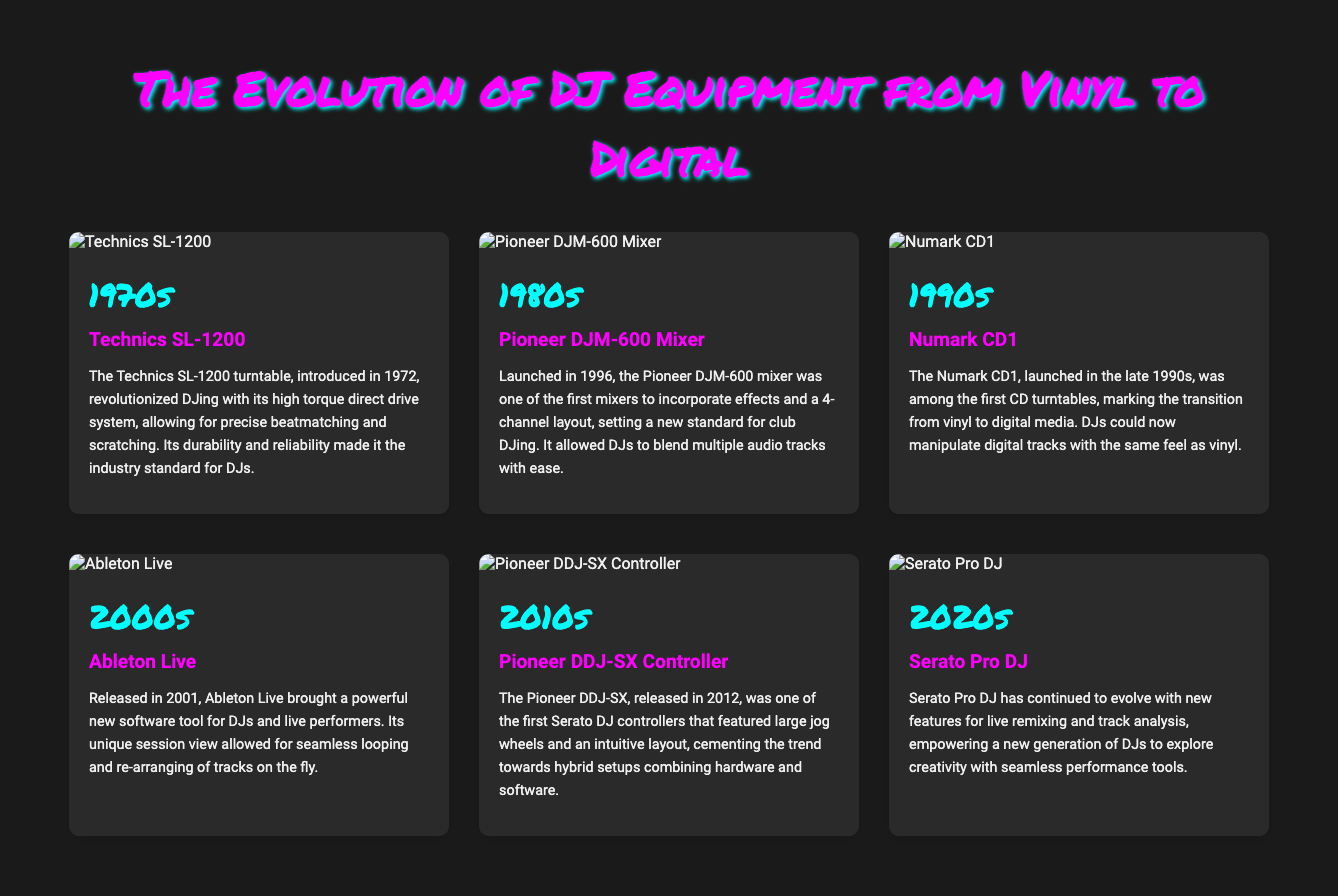What year was the Technics SL-1200 released? The Technics SL-1200 was introduced in 1972, which is explicitly stated in the document.
Answer: 1972 What was the key invention of the 1980s? The document mentions the Pioneer DJM-600 Mixer as the key invention from that decade.
Answer: Pioneer DJM-600 Mixer What technology did the Numark CD1 represent? The document states that the Numark CD1 marked the transition from vinyl to digital media, emphasizing a significant change in DJ technology.
Answer: Transition from vinyl to digital What major software was released in 2001? The document specifies that Ableton Live was released in 2001, which is a key detail highlighted in the timeline.
Answer: Ableton Live Which DJ controller was released in 2012? The document identifies the Pioneer DDJ-SX Controller as the significant development for the 2010s.
Answer: Pioneer DDJ-SX Controller What does Serato Pro DJ empower DJs to do? The document notes that Serato Pro DJ empowers a new generation of DJs to explore creativity with seamless performance tools, showcasing its innovative approach.
Answer: Explore creativity How many decades are covered in this visual timeline? The document discusses advancements over six decades in DJ equipment, detailing each era's developments.
Answer: Six decades What is the image at the top of the timeline? The timeline begins with an image of the Technics SL-1200, setting the stage for the discussion of DJ equipment evolution.
Answer: Technics SL-1200 What color scheme is used in the timeline's title? The title utilizes a color scheme of pink and cyan, which creates a vibrant and eye-catching highlight for the timeline section.
Answer: Pink and cyan 